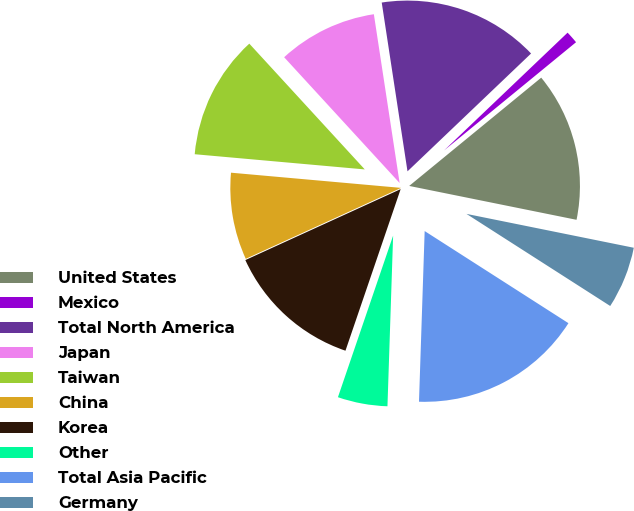Convert chart. <chart><loc_0><loc_0><loc_500><loc_500><pie_chart><fcel>United States<fcel>Mexico<fcel>Total North America<fcel>Japan<fcel>Taiwan<fcel>China<fcel>Korea<fcel>Other<fcel>Total Asia Pacific<fcel>Germany<nl><fcel>14.11%<fcel>1.19%<fcel>15.29%<fcel>9.41%<fcel>11.76%<fcel>8.24%<fcel>12.94%<fcel>4.71%<fcel>16.46%<fcel>5.89%<nl></chart> 